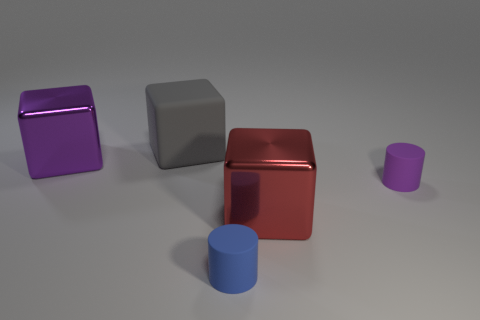There is a tiny thing behind the tiny blue cylinder; is it the same color as the metal object that is right of the purple block?
Offer a very short reply. No. There is a object that is both behind the tiny blue rubber cylinder and in front of the purple rubber object; what is its material?
Your answer should be compact. Metal. Are there any large red cylinders?
Provide a succinct answer. No. The small purple thing that is made of the same material as the gray object is what shape?
Provide a succinct answer. Cylinder. Do the big matte thing and the large shiny thing that is behind the tiny purple cylinder have the same shape?
Your response must be concise. Yes. There is a cylinder in front of the large metallic cube on the right side of the blue object; what is its material?
Offer a very short reply. Rubber. How many other things are there of the same shape as the small purple matte thing?
Your answer should be compact. 1. There is a purple thing that is on the left side of the gray block; is its shape the same as the large metallic thing that is on the right side of the big purple cube?
Offer a very short reply. Yes. Are there any other things that have the same material as the big purple object?
Your answer should be very brief. Yes. What is the material of the red thing?
Make the answer very short. Metal. 